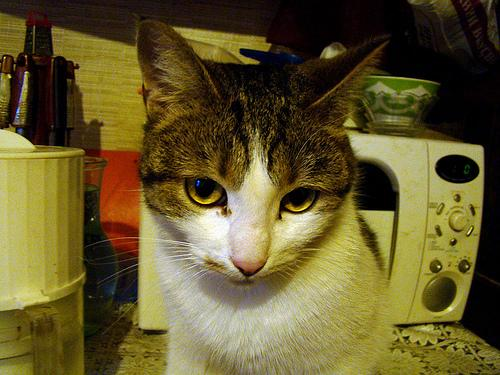What emotions or feelings do the cat's ears convey? Curiosity or alertness due to their tilted position. List three items that can be found on or near the microwave. Green bowl, glass bowl, and a vase with blue liquid. Describe the table or counter where the scene is taking place. The table or counter has a nonslip lining, a white flower-patterned plastic tablecloth, and a fold in the tablecloth. In simple language, mention the main objects present in the image. There is a cat, a microwave, a table, a vase, a bowl, and kitchen utensils. How many bowls are mentioned and what are their colors? Two bowls – one green and one white. What are some features of the cat's face? Yellow eyes, pale pink nose, tilted ears, and white whiskers. Identify the main object and describe its appearance in detail. The main object is a white, grey, and black cat with amber runny eyes, small pale pink nose, tilted ears, and white whiskers showing curiosity or alertness. Can you provide a description of the microwave and its accessories? The microwave is a dirty white with buttons and dials, a timer display, a large grey button, and a control button. Provide a brief description of the scene in the image. A cute white and tabby cat is sitting on a counter or table while surrounded by various items such as a dirty microwave, green bowl, a vase with blue liquid, and kitchen utensils. What type of feline is the primary focus of the image? A white and tabby cat with yellow eyes and a pink nose. Are the cat's eyes bright blue in color? No, it's not mentioned in the image. 